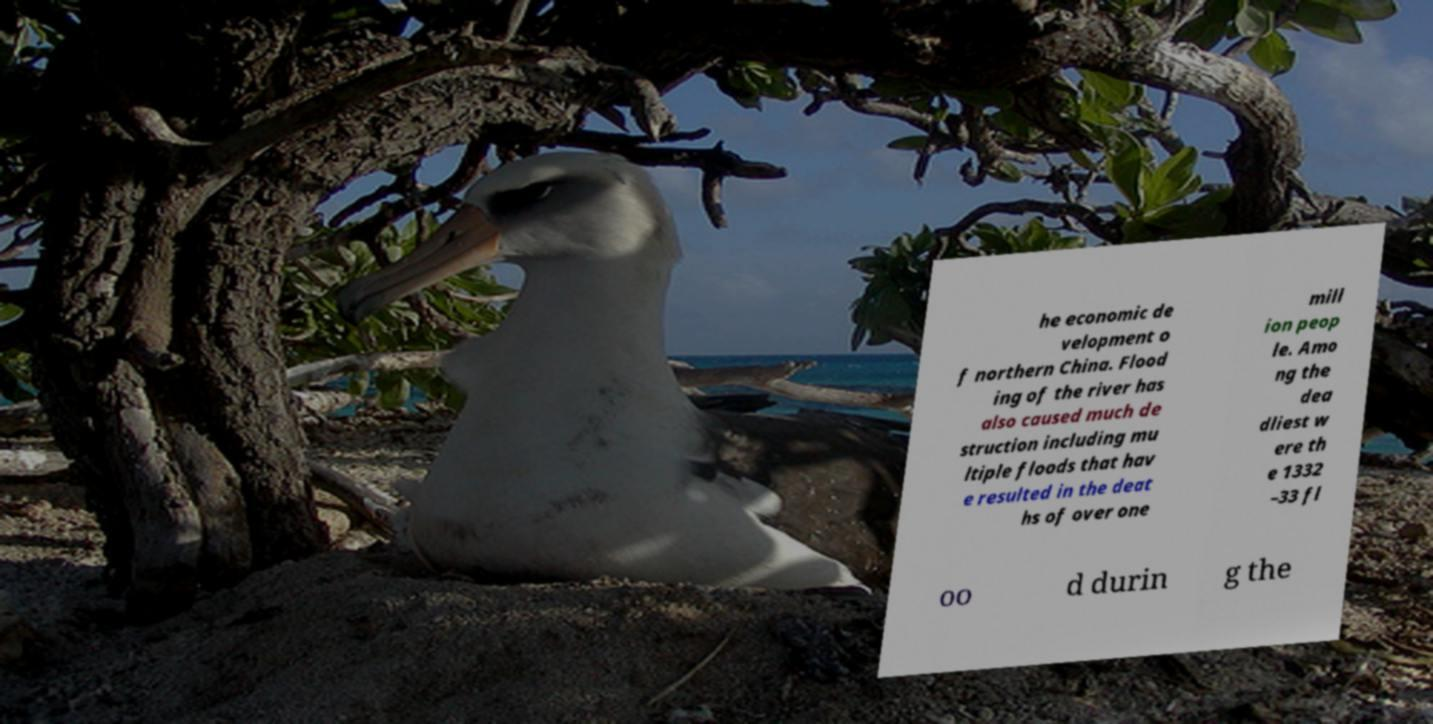Could you extract and type out the text from this image? he economic de velopment o f northern China. Flood ing of the river has also caused much de struction including mu ltiple floods that hav e resulted in the deat hs of over one mill ion peop le. Amo ng the dea dliest w ere th e 1332 –33 fl oo d durin g the 